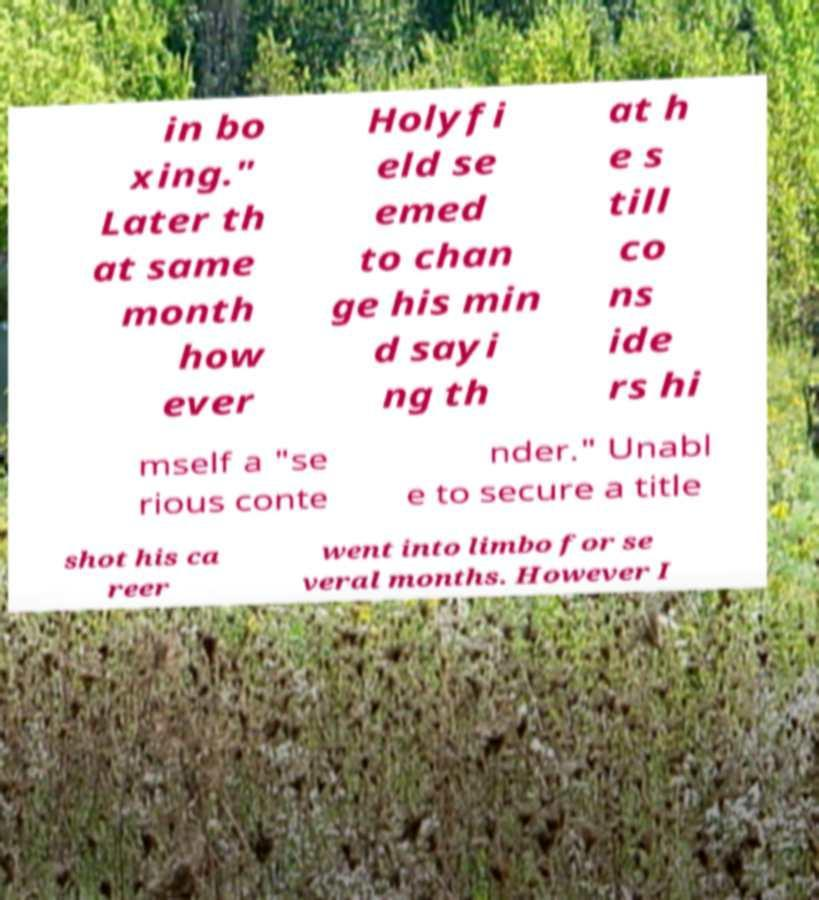I need the written content from this picture converted into text. Can you do that? in bo xing." Later th at same month how ever Holyfi eld se emed to chan ge his min d sayi ng th at h e s till co ns ide rs hi mself a "se rious conte nder." Unabl e to secure a title shot his ca reer went into limbo for se veral months. However I 